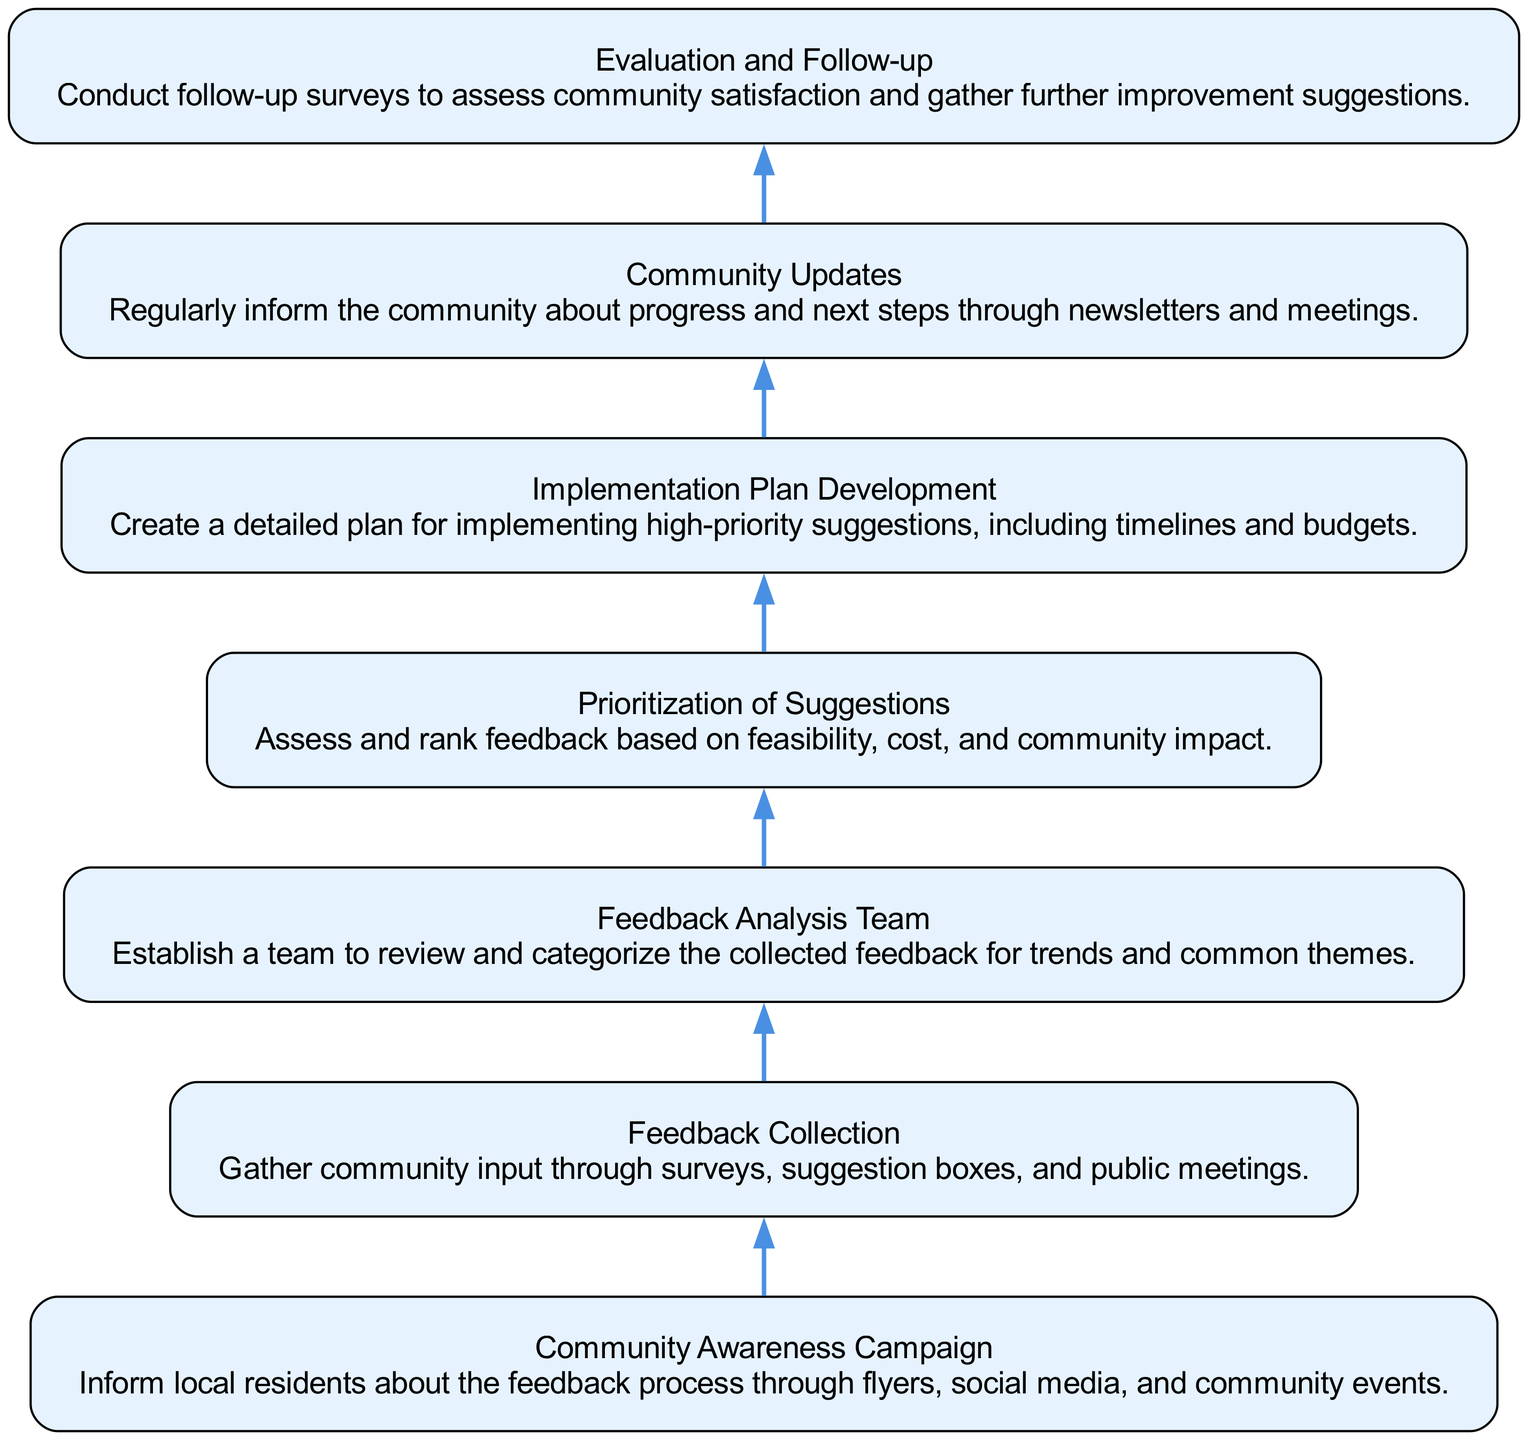What is the first step in the flow chart? The first step is "Community Awareness Campaign," which is the starting point of the diagram. It is the initial action taken to inform local residents about the feedback process.
Answer: Community Awareness Campaign How many nodes are there in total? The diagram features seven distinct elements, each representing a step in the community feedback process, leading to a total of seven nodes.
Answer: 7 What is the last step in the flow chart? The last step is "Evaluation and Follow-up," indicating that the process concludes with assessing community satisfaction and gathering further suggestions.
Answer: Evaluation and Follow-up What two nodes are connected directly to "Feedback Analysis Team"? The "Feedback Collection" node connects directly to "Feedback Analysis Team" as it leads into the analysis of the collected data, and "Prioritization of Suggestions" comes afterward as the logical next step.
Answer: Feedback Collection, Prioritization of Suggestions Which step involves informing the community about progress? The step dedicated to keeping the community informed is "Community Updates," which emphasizes communication about the project's progress and next steps.
Answer: Community Updates What is assessed during the "Prioritization of Suggestions" step? In this step, feedback is evaluated based on its feasibility, cost, and the impact it has on the community, which allows for a structured approach to selecting suggestions for implementation.
Answer: Feasibility, cost, and community impact What connects the "Feedback Collection" to "Feedback Analysis Team"? The connection between these two nodes represents the process whereby feedback collected from various sources is handed over to the analysis team for examination and categorization.
Answer: Analysis process What do the "Community Awareness Campaign" and "Feedback Collection" steps represent together? Together, these two steps represent the initial outreach and engagement efforts to gather useful input from the community, creating the foundation of the feedback process.
Answer: Initial outreach and engagement efforts 